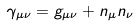Convert formula to latex. <formula><loc_0><loc_0><loc_500><loc_500>\gamma _ { \mu \nu } = g _ { \mu \nu } + n _ { \mu } n _ { \nu }</formula> 